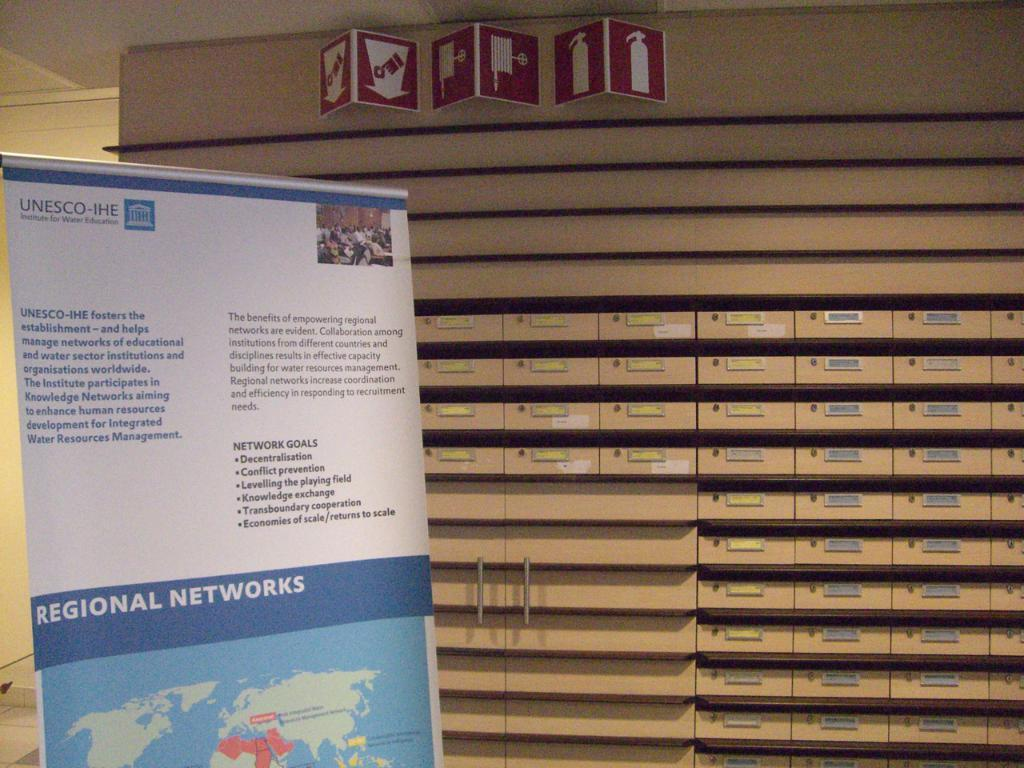<image>
Provide a brief description of the given image. A large UNESCO-IHE sign with the mention of regional networks 